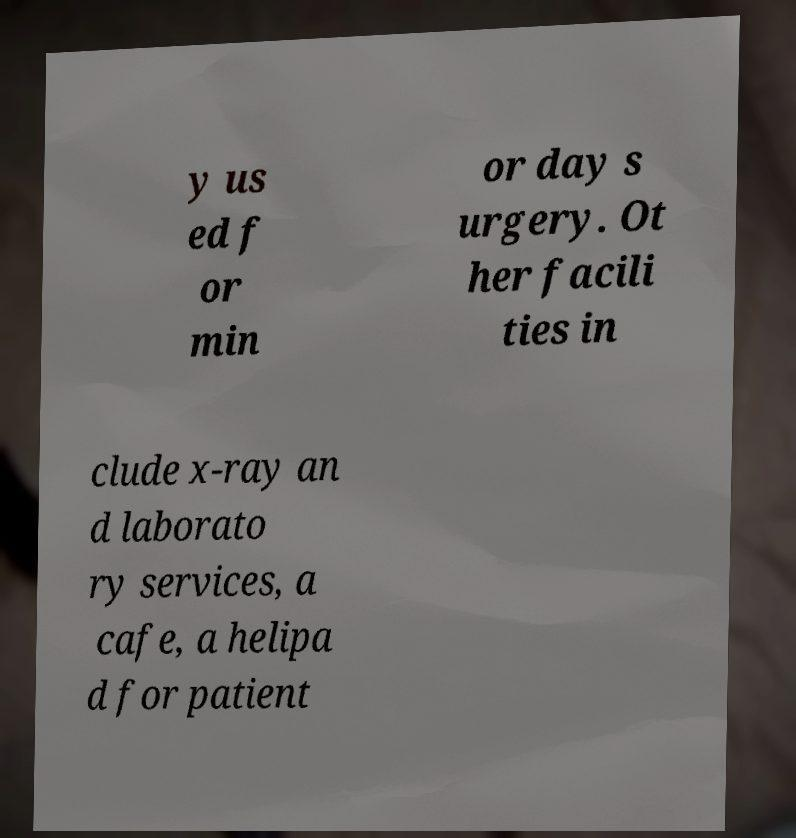Can you read and provide the text displayed in the image?This photo seems to have some interesting text. Can you extract and type it out for me? y us ed f or min or day s urgery. Ot her facili ties in clude x-ray an d laborato ry services, a cafe, a helipa d for patient 